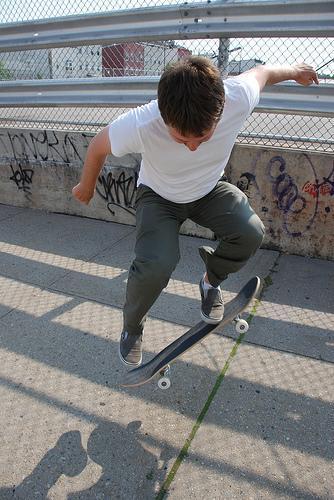How many people are there?
Give a very brief answer. 1. 